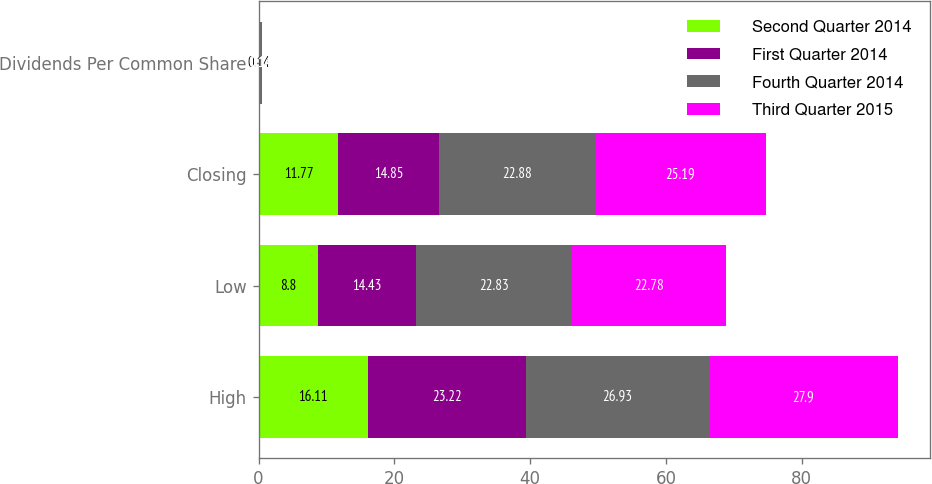Convert chart. <chart><loc_0><loc_0><loc_500><loc_500><stacked_bar_chart><ecel><fcel>High<fcel>Low<fcel>Closing<fcel>Dividends Per Common Share<nl><fcel>Second Quarter 2014<fcel>16.11<fcel>8.8<fcel>11.77<fcel>0.14<nl><fcel>First Quarter 2014<fcel>23.22<fcel>14.43<fcel>14.85<fcel>0.14<nl><fcel>Fourth Quarter 2014<fcel>26.93<fcel>22.83<fcel>22.88<fcel>0.14<nl><fcel>Third Quarter 2015<fcel>27.9<fcel>22.78<fcel>25.19<fcel>0.14<nl></chart> 